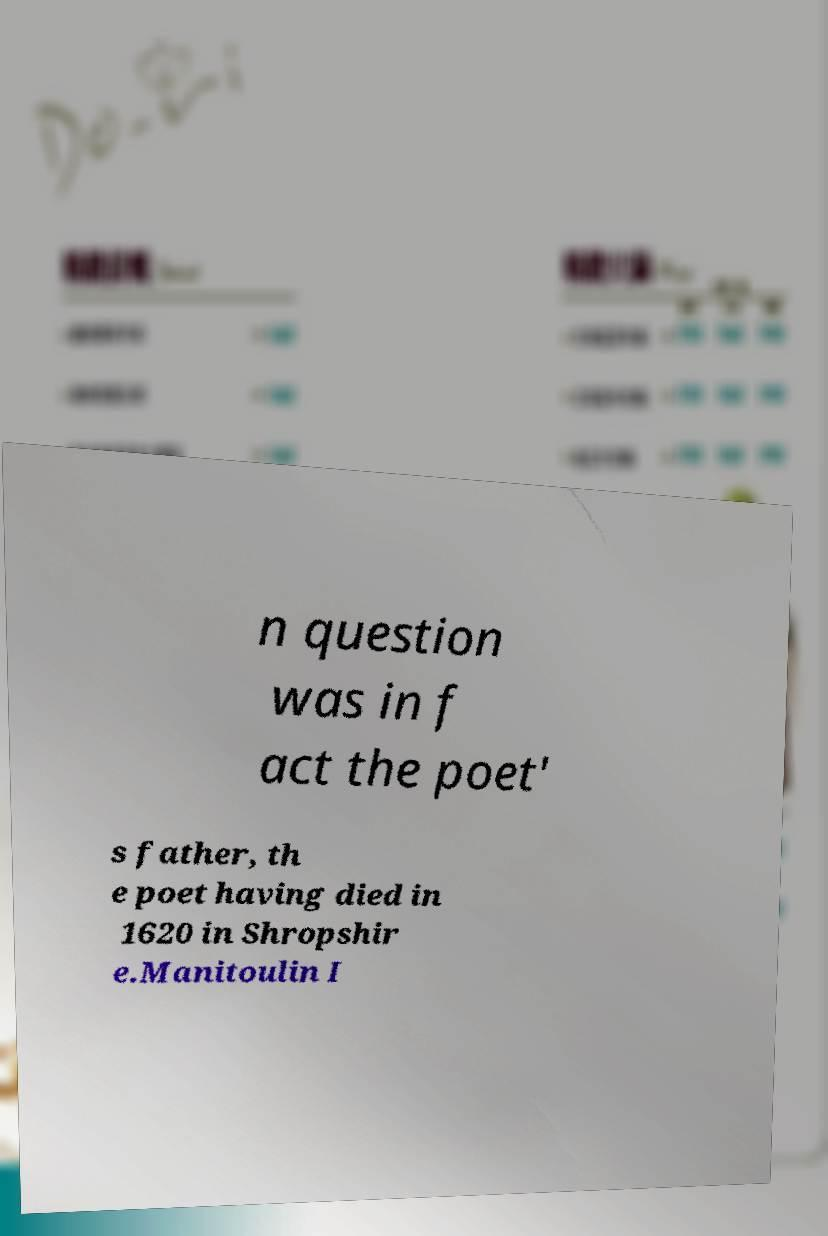Can you read and provide the text displayed in the image?This photo seems to have some interesting text. Can you extract and type it out for me? n question was in f act the poet' s father, th e poet having died in 1620 in Shropshir e.Manitoulin I 